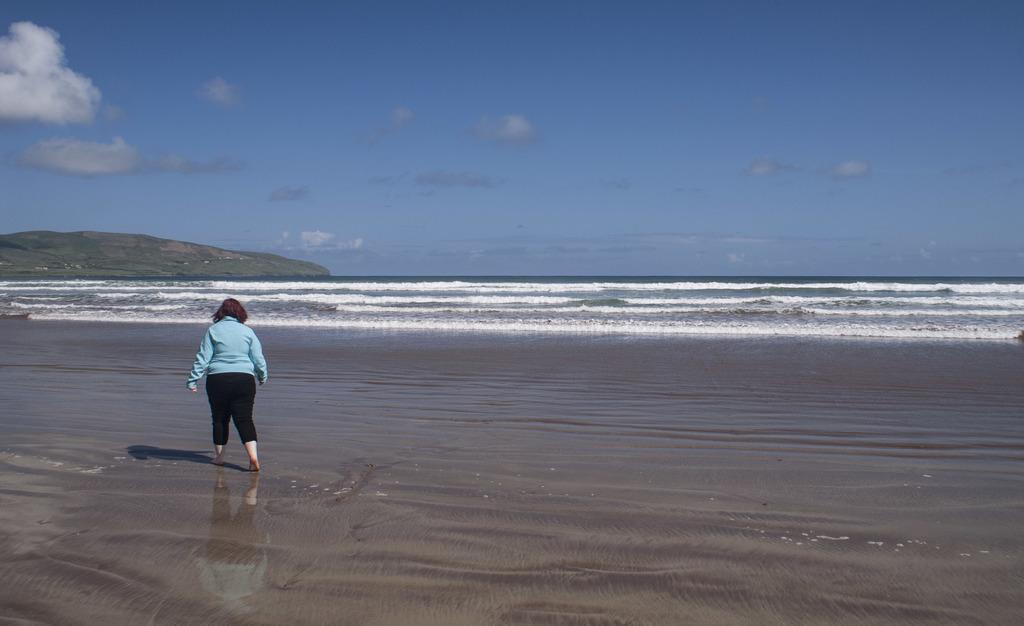How would you summarize this image in a sentence or two? In this picture there is a person walking and we can see water and hill. In the background of the image we can see the sky with clouds. 